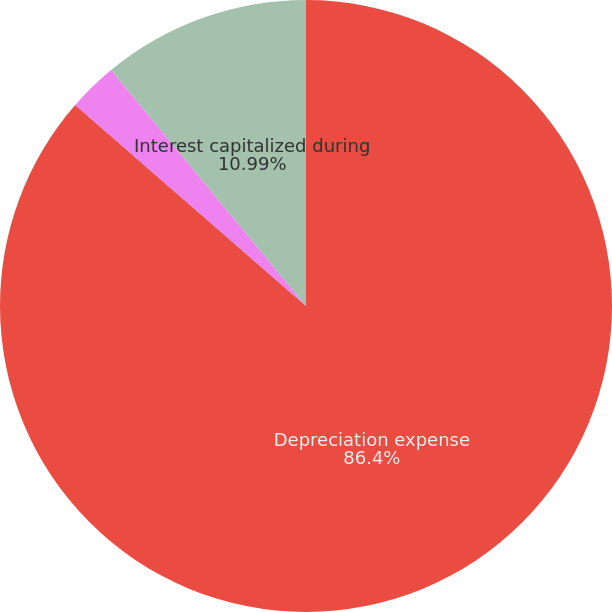Convert chart to OTSL. <chart><loc_0><loc_0><loc_500><loc_500><pie_chart><fcel>Depreciation expense<fcel>Amortization of internal-use<fcel>Interest capitalized during<nl><fcel>86.41%<fcel>2.61%<fcel>10.99%<nl></chart> 